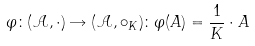Convert formula to latex. <formula><loc_0><loc_0><loc_500><loc_500>\varphi \colon ( \mathcal { A } , \cdot ) \rightarrow ( \mathcal { A } , \circ _ { K } ) \colon \varphi ( A ) = \frac { 1 } { K } \cdot A</formula> 